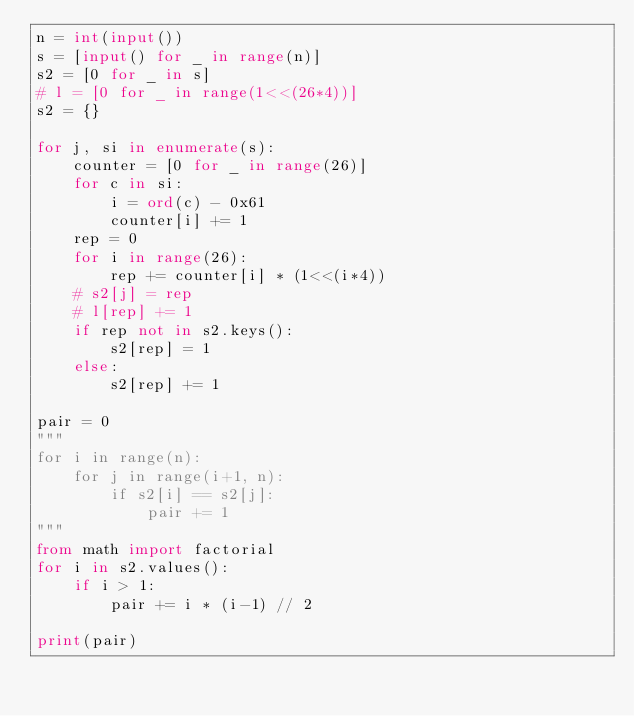Convert code to text. <code><loc_0><loc_0><loc_500><loc_500><_Python_>n = int(input())
s = [input() for _ in range(n)]
s2 = [0 for _ in s]
# l = [0 for _ in range(1<<(26*4))]
s2 = {}

for j, si in enumerate(s):
    counter = [0 for _ in range(26)]
    for c in si:
        i = ord(c) - 0x61
        counter[i] += 1
    rep = 0
    for i in range(26):
        rep += counter[i] * (1<<(i*4))
    # s2[j] = rep
    # l[rep] += 1
    if rep not in s2.keys():
        s2[rep] = 1
    else:
        s2[rep] += 1

pair = 0
"""
for i in range(n):
    for j in range(i+1, n):
        if s2[i] == s2[j]:
            pair += 1
"""
from math import factorial
for i in s2.values():
    if i > 1:
        pair += i * (i-1) // 2 

print(pair)
</code> 